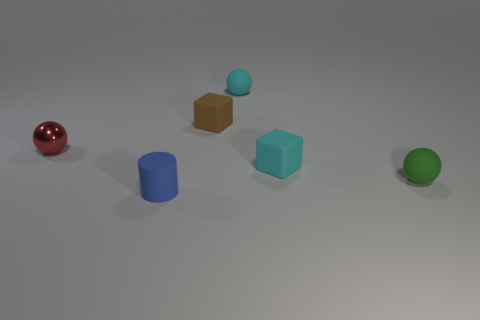Subtract all small matte balls. How many balls are left? 1 Add 4 metal spheres. How many objects exist? 10 Subtract all blocks. How many objects are left? 4 Subtract 1 blocks. How many blocks are left? 1 Subtract all brown cubes. How many cubes are left? 1 Subtract all purple cylinders. Subtract all green spheres. How many cylinders are left? 1 Subtract all cyan blocks. How many red balls are left? 1 Subtract all red matte things. Subtract all tiny green spheres. How many objects are left? 5 Add 5 small brown blocks. How many small brown blocks are left? 6 Add 6 green spheres. How many green spheres exist? 7 